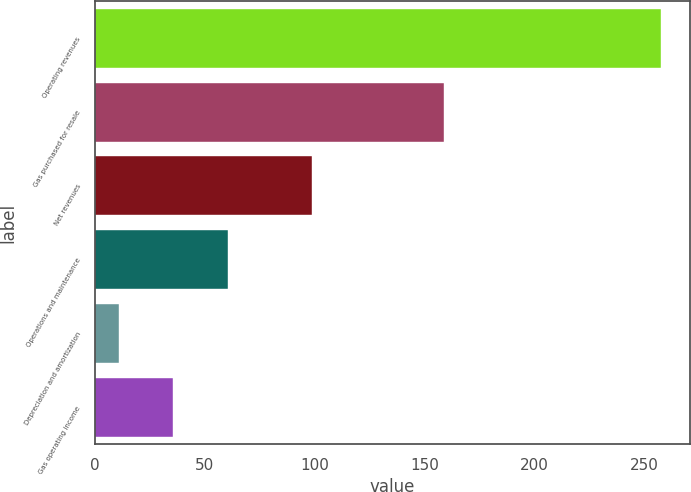Convert chart to OTSL. <chart><loc_0><loc_0><loc_500><loc_500><bar_chart><fcel>Operating revenues<fcel>Gas purchased for resale<fcel>Net revenues<fcel>Operations and maintenance<fcel>Depreciation and amortization<fcel>Gas operating income<nl><fcel>258<fcel>159<fcel>99<fcel>60.4<fcel>11<fcel>35.7<nl></chart> 